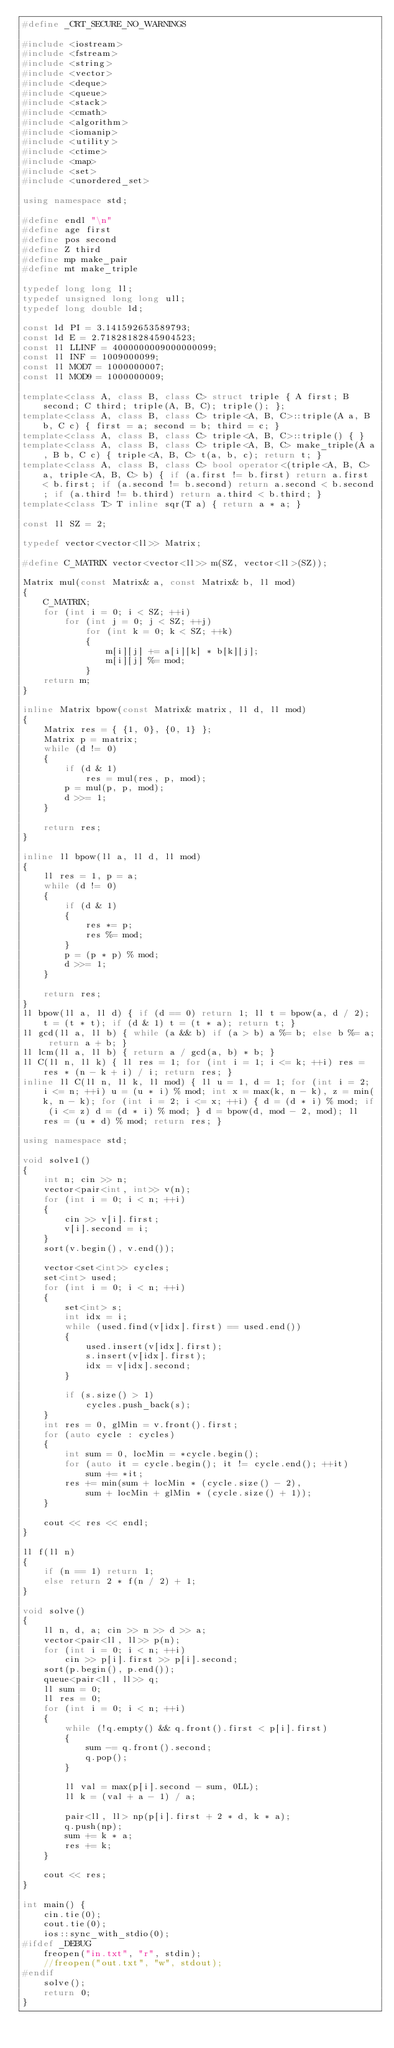<code> <loc_0><loc_0><loc_500><loc_500><_C++_>#define _CRT_SECURE_NO_WARNINGS

#include <iostream>
#include <fstream>
#include <string>
#include <vector>
#include <deque>
#include <queue>
#include <stack>
#include <cmath>
#include <algorithm>
#include <iomanip>
#include <utility>
#include <ctime>
#include <map>
#include <set>
#include <unordered_set>

using namespace std;

#define endl "\n"
#define age first
#define pos second
#define Z third
#define mp make_pair
#define mt make_triple

typedef long long ll;
typedef unsigned long long ull;
typedef long double ld;

const ld PI = 3.141592653589793;
const ld E = 2.71828182845904523;
const ll LLINF = 4000000009000000099;
const ll INF = 1009000099;
const ll MOD7 = 1000000007;
const ll MOD9 = 1000000009;

template<class A, class B, class C> struct triple { A first; B second; C third; triple(A, B, C); triple(); };
template<class A, class B, class C> triple<A, B, C>::triple(A a, B b, C c) { first = a; second = b; third = c; }
template<class A, class B, class C> triple<A, B, C>::triple() { }
template<class A, class B, class C> triple<A, B, C> make_triple(A a, B b, C c) { triple<A, B, C> t(a, b, c); return t; }
template<class A, class B, class C> bool operator<(triple<A, B, C> a, triple<A, B, C> b) { if (a.first != b.first) return a.first < b.first; if (a.second != b.second) return a.second < b.second; if (a.third != b.third) return a.third < b.third; }
template<class T> T inline sqr(T a) { return a * a; }

const ll SZ = 2;

typedef vector<vector<ll>> Matrix;

#define C_MATRIX vector<vector<ll>> m(SZ, vector<ll>(SZ));

Matrix mul(const Matrix& a, const Matrix& b, ll mod)
{
	C_MATRIX;
	for (int i = 0; i < SZ; ++i)
		for (int j = 0; j < SZ; ++j)
			for (int k = 0; k < SZ; ++k)
			{
				m[i][j] += a[i][k] * b[k][j];
				m[i][j] %= mod;
			}
	return m;
}

inline Matrix bpow(const Matrix& matrix, ll d, ll mod)
{
	Matrix res = { {1, 0}, {0, 1} };
	Matrix p = matrix;
	while (d != 0)
	{
		if (d & 1)
			res = mul(res, p, mod);
		p = mul(p, p, mod);
		d >>= 1;
	}

	return res;
}

inline ll bpow(ll a, ll d, ll mod)
{
	ll res = 1, p = a;
	while (d != 0)
	{
		if (d & 1)
		{
			res *= p;
			res %= mod;
		}
		p = (p * p) % mod;
		d >>= 1;
	}

	return res;
}
ll bpow(ll a, ll d) { if (d == 0) return 1; ll t = bpow(a, d / 2); t = (t * t); if (d & 1) t = (t * a); return t; }
ll gcd(ll a, ll b) { while (a && b) if (a > b) a %= b; else b %= a; return a + b; }
ll lcm(ll a, ll b) { return a / gcd(a, b) * b; }
ll C(ll n, ll k) { ll res = 1; for (int i = 1; i <= k; ++i) res = res * (n - k + i) / i; return res; }
inline ll C(ll n, ll k, ll mod) { ll u = 1, d = 1; for (int i = 2; i <= n; ++i) u = (u * i) % mod; int x = max(k, n - k), z = min(k, n - k); for (int i = 2; i <= x; ++i) { d = (d * i) % mod; if (i <= z) d = (d * i) % mod; } d = bpow(d, mod - 2, mod); ll res = (u * d) % mod; return res; }

using namespace std;

void solve1()
{
	int n; cin >> n;
	vector<pair<int, int>> v(n);
	for (int i = 0; i < n; ++i)
	{
		cin >> v[i].first;
		v[i].second = i;
	}
	sort(v.begin(), v.end());

	vector<set<int>> cycles;
	set<int> used;
	for (int i = 0; i < n; ++i)
	{
		set<int> s;
		int idx = i;
		while (used.find(v[idx].first) == used.end())
		{
			used.insert(v[idx].first);
			s.insert(v[idx].first);
			idx = v[idx].second;
		}

		if (s.size() > 1)
			cycles.push_back(s);
	}
	int res = 0, glMin = v.front().first;
	for (auto cycle : cycles)
	{
		int sum = 0, locMin = *cycle.begin();
		for (auto it = cycle.begin(); it != cycle.end(); ++it)
			sum += *it;
		res += min(sum + locMin * (cycle.size() - 2),
			sum + locMin + glMin * (cycle.size() + 1));
	}

	cout << res << endl;
}

ll f(ll n)
{
	if (n == 1) return 1;
	else return 2 * f(n / 2) + 1;
}

void solve()
{
	ll n, d, a; cin >> n >> d >> a;
	vector<pair<ll, ll>> p(n);
	for (int i = 0; i < n; ++i)
		cin >> p[i].first >> p[i].second;
	sort(p.begin(), p.end());
	queue<pair<ll, ll>> q;
	ll sum = 0;
	ll res = 0;
	for (int i = 0; i < n; ++i)
	{
		while (!q.empty() && q.front().first < p[i].first)
		{
			sum -= q.front().second;
			q.pop();
		}

		ll val = max(p[i].second - sum, 0LL);
		ll k = (val + a - 1) / a;

		pair<ll, ll> np(p[i].first + 2 * d, k * a);
		q.push(np);
		sum += k * a;
		res += k;
	}

	cout << res;
}

int main() {
	cin.tie(0);
	cout.tie(0);
	ios::sync_with_stdio(0);
#ifdef _DEBUG
	freopen("in.txt", "r", stdin);
	//freopen("out.txt", "w", stdout);
#endif
	solve();
	return 0;
}
</code> 